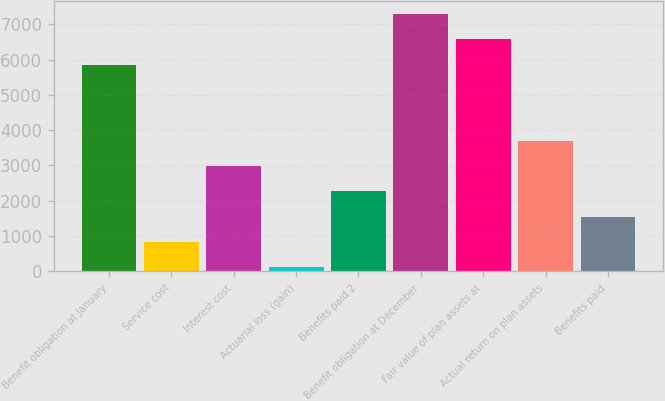<chart> <loc_0><loc_0><loc_500><loc_500><bar_chart><fcel>Benefit obligation at January<fcel>Service cost<fcel>Interest cost<fcel>Actuarial loss (gain)<fcel>Benefits paid 2<fcel>Benefit obligation at December<fcel>Fair value of plan assets at<fcel>Actual return on plan assets<fcel>Benefits paid<nl><fcel>5855.4<fcel>827.3<fcel>2982.2<fcel>109<fcel>2263.9<fcel>7292<fcel>6573.7<fcel>3700.5<fcel>1545.6<nl></chart> 